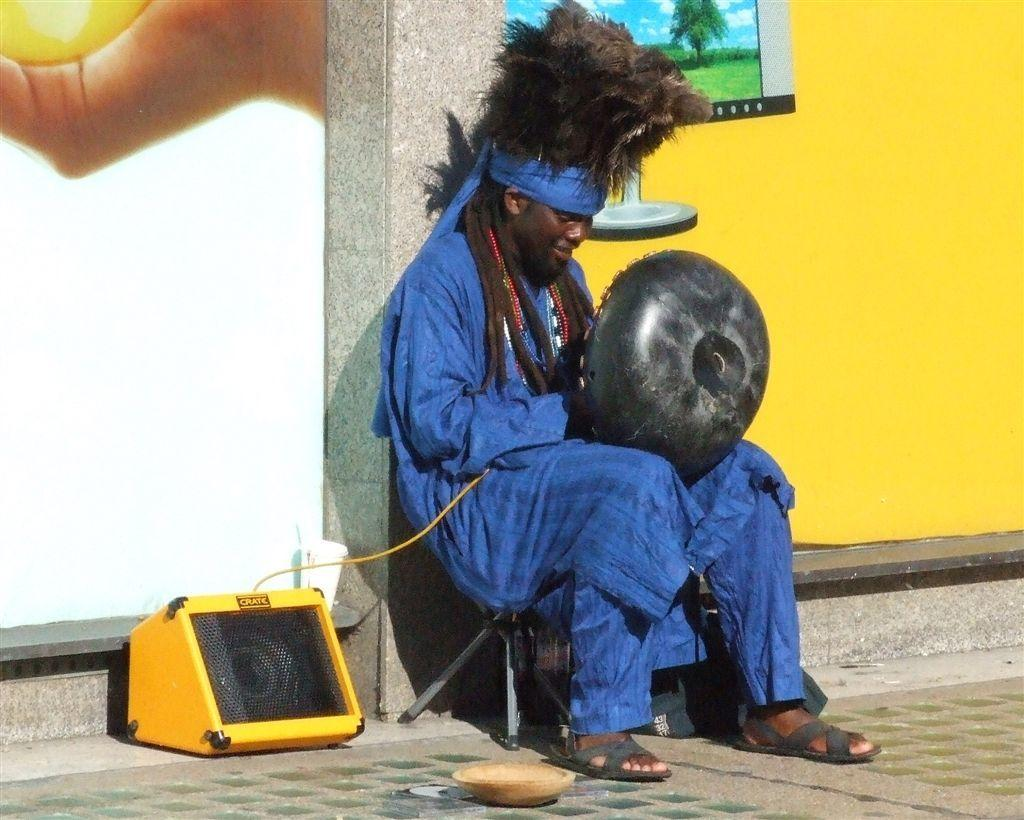What is the man in the image doing? The man is sitting on a stool in the image. What is the man holding in the image? The man is holding an object in the image. What can be seen beside the man? There is a speaker beside the man in the image. What is visible behind the man? There is a wall behind the man in the image, and there are pictures on the wall. What type of division can be seen occurring in the image? There is no division occurring in the image; it is a static scene with a man sitting on a stool, holding an object, and a speaker beside him. How does the rice play a role in the image? There is no rice present in the image, so it does not play any role. 